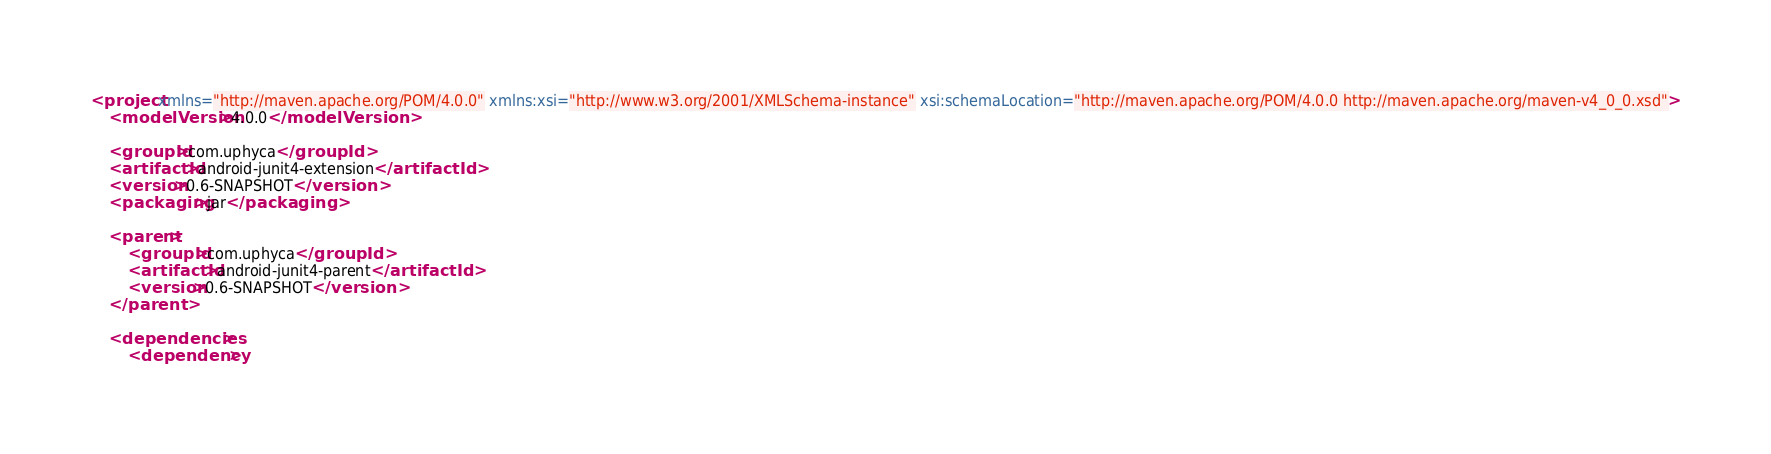Convert code to text. <code><loc_0><loc_0><loc_500><loc_500><_XML_><project xmlns="http://maven.apache.org/POM/4.0.0" xmlns:xsi="http://www.w3.org/2001/XMLSchema-instance" xsi:schemaLocation="http://maven.apache.org/POM/4.0.0 http://maven.apache.org/maven-v4_0_0.xsd">
	<modelVersion>4.0.0</modelVersion>

	<groupId>com.uphyca</groupId>
	<artifactId>android-junit4-extension</artifactId>
	<version>0.6-SNAPSHOT</version>
	<packaging>jar</packaging>
	
	<parent>
		<groupId>com.uphyca</groupId>
		<artifactId>android-junit4-parent</artifactId>
		<version>0.6-SNAPSHOT</version>
	</parent>

	<dependencies>
		<dependency></code> 